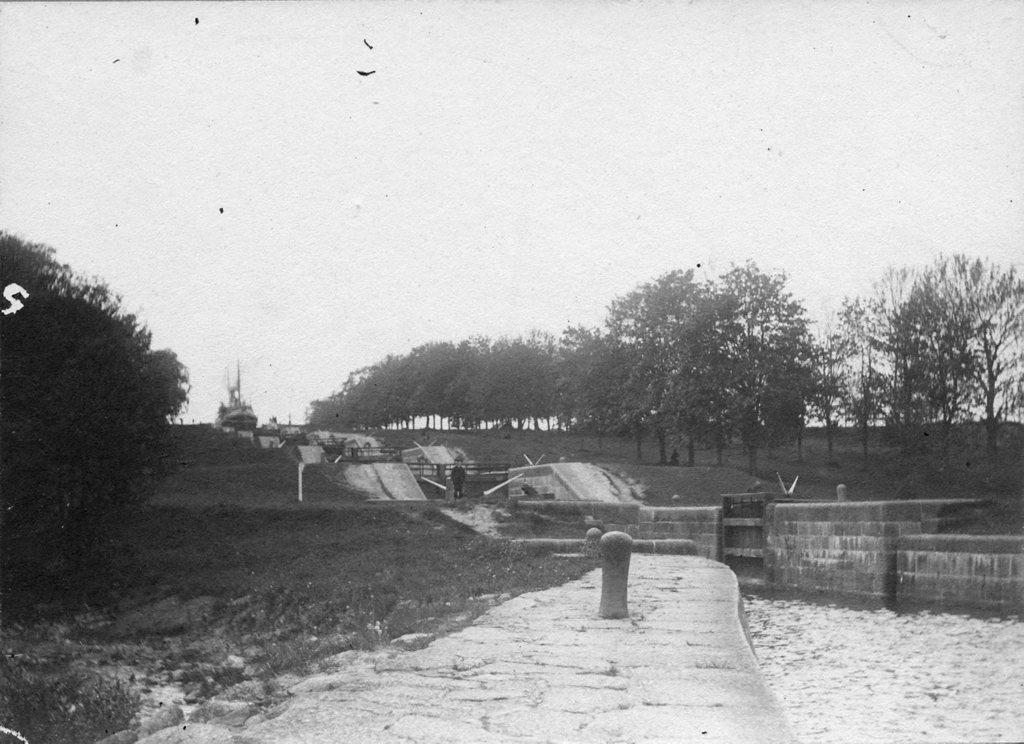What is the color scheme of the image? The image is black and white. What is the main subject of the image? There is a ship in the image. What type of environment is depicted in the image? There is water, trees, and grass visible in the image. What else can be seen in the image? There are persons in the image. What is visible in the background of the image? The sky is visible in the image. What type of business is being conducted by the persons in the image? There is no indication of any business being conducted in the image; it simply shows a ship in a natural environment with persons present. Can you tell me which guide is leading the group of persons in the image? There is no guide or group of persons being led in the image; it only shows a few individuals near the ship. 